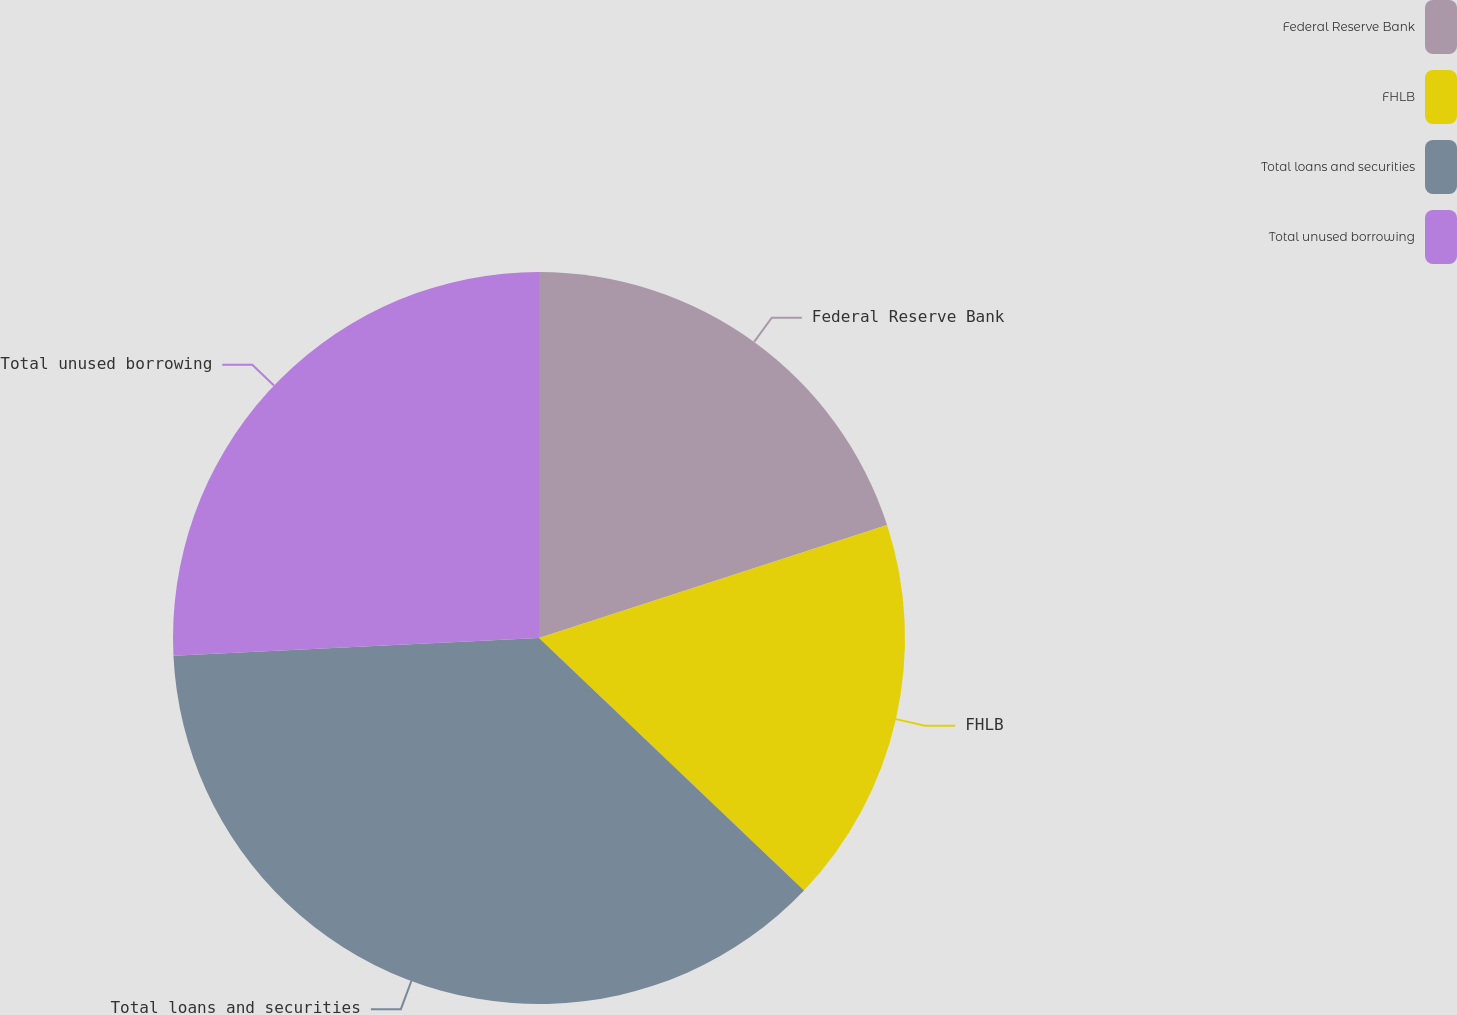<chart> <loc_0><loc_0><loc_500><loc_500><pie_chart><fcel>Federal Reserve Bank<fcel>FHLB<fcel>Total loans and securities<fcel>Total unused borrowing<nl><fcel>20.0%<fcel>17.11%<fcel>37.11%<fcel>25.77%<nl></chart> 